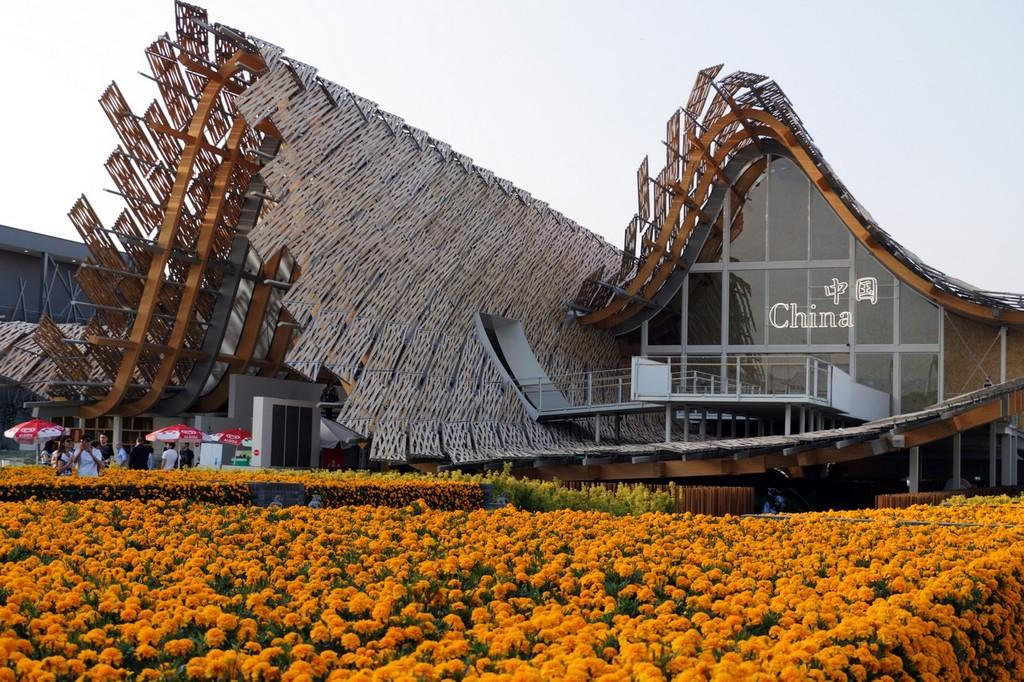What type of structures can be seen in the image? There are buildings in the image. Are there any living beings present in the image? Yes, there are people in the image. What might be used to protect against rain in the image? Umbrellas are present in the image. What type of vegetation can be seen in the image? There are flowers in the garden in the image. What is visible in the sky in the image? The sky is visible in the image. What type of leather is being used to make the goldfish float in the image? There is no leather or goldfish present in the image. 